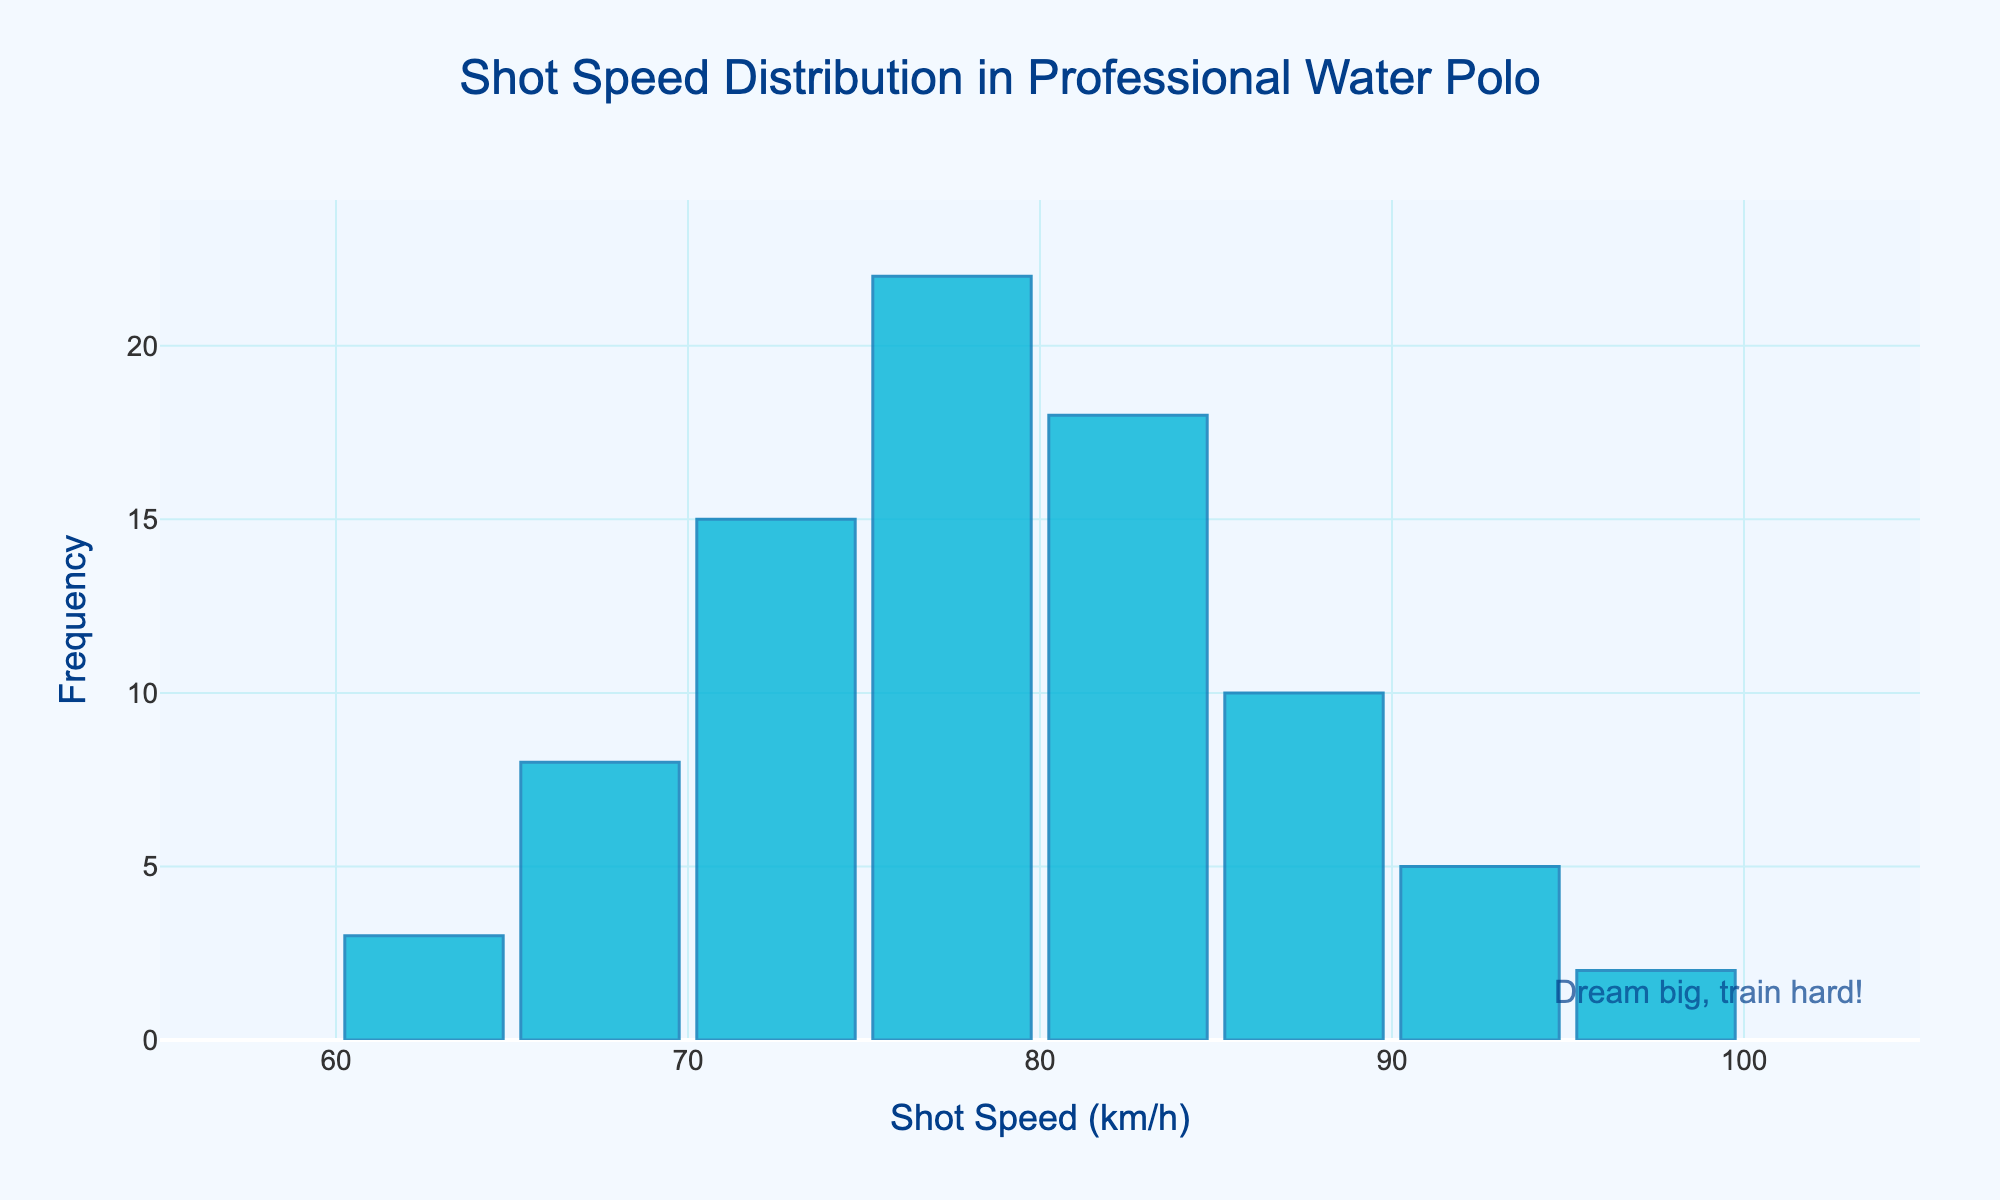What is the title of the histogram? The title is located at the top center of the histogram, clearly indicating what the data represents.
Answer: Shot Speed Distribution in Professional Water Polo What is the most frequent shot speed range? The bar with the highest frequency represents the most common shot speed range, which is between 75-80 km/h.
Answer: 75-80 km/h What is the frequency of shots in the 80-85 km/h range? The height of the bar corresponding to the 80-85 km/h range on the x-axis indicates the frequency, which is 18.
Answer: 18 How many different shot speed ranges are shown in the histogram? Counting the distinct bars on the x-axis gives us the number of shot speed ranges displayed in the histogram.
Answer: 8 Compare the frequencies of shots between 70-75 km/h and 85-90 km/h. Which range has a higher frequency? We compare the heights of the bars for the 70-75 km/h and 85-90 km/h ranges. The 70-75 km/h range has a frequency of 15, which is higher than the 85-90 km/h range, which is 10.
Answer: 70-75 km/h What is the frequency difference between the 75-80 km/h and 90-95 km/h shot speeds? Subtracting the frequency of the 90-95 km/h range (5) from the frequency of the 75-80 km/h range (22) gives the difference.
Answer: 17 Which shot speed range has the second highest frequency? Identifying the bar with the second highest height, after the highest one which is 75-80 km/h, shows that the 80-85 km/h range has the second highest frequency.
Answer: 80-85 km/h What is the average frequency of the bins on the histogram? Summing up the frequencies (3 + 8 + 15 + 22 + 18 + 10 + 5 + 2 = 83) and dividing by the number of bins (8) gives the average frequency. 83 / 8 = 10.375
Answer: 10.375 If a player wants to be in the top 10% of shot speeds, what range should they aim for? To be in the top 10% of shot speeds, players should aim for the highest range shown on the histogram, which is 95-100 km/h.
Answer: 95-100 km/h 